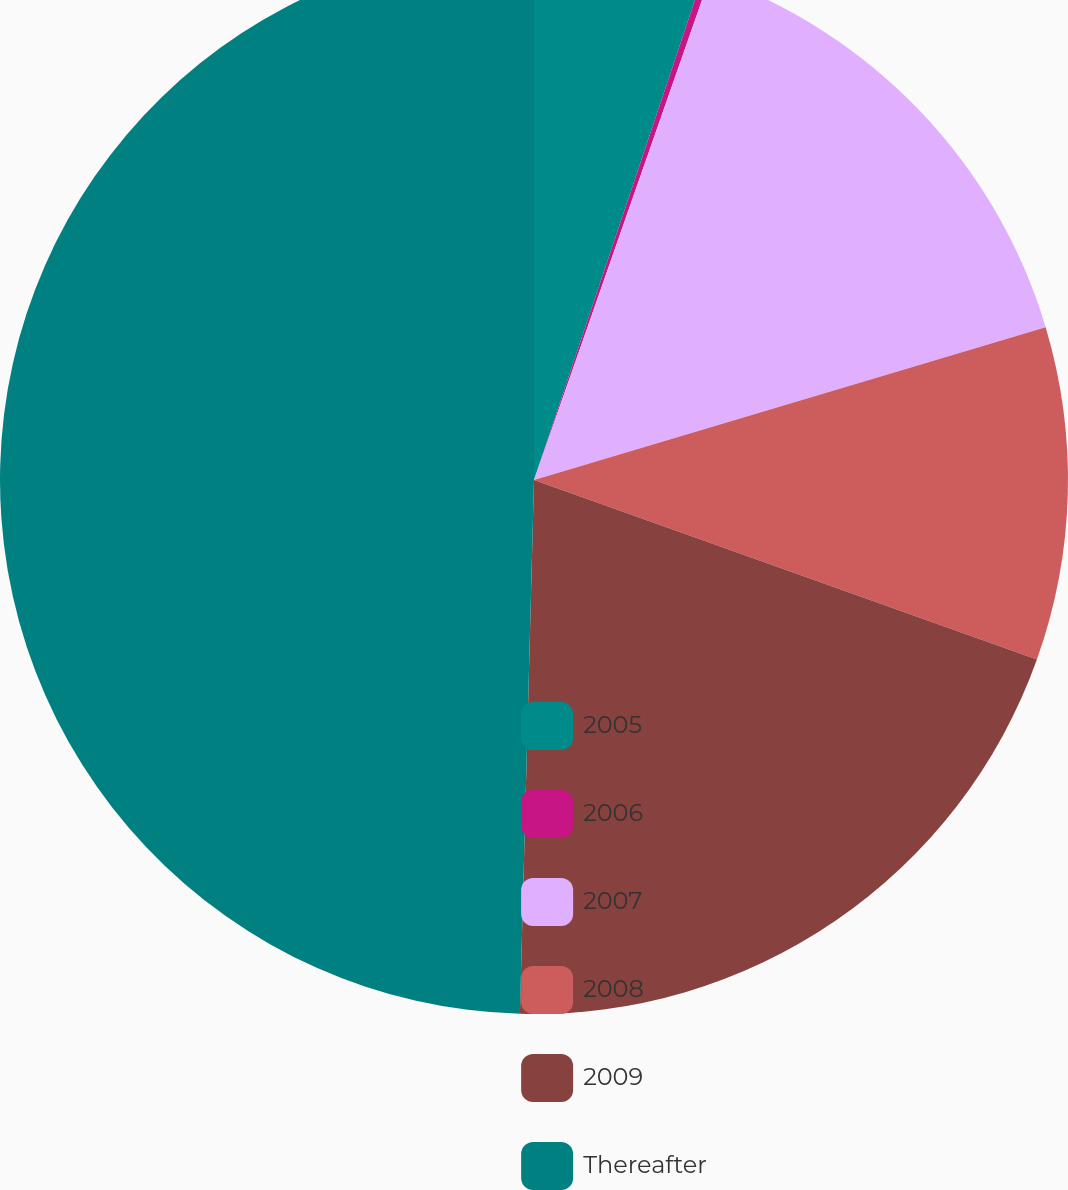Convert chart to OTSL. <chart><loc_0><loc_0><loc_500><loc_500><pie_chart><fcel>2005<fcel>2006<fcel>2007<fcel>2008<fcel>2009<fcel>Thereafter<nl><fcel>5.15%<fcel>0.21%<fcel>15.02%<fcel>10.08%<fcel>19.96%<fcel>49.58%<nl></chart> 